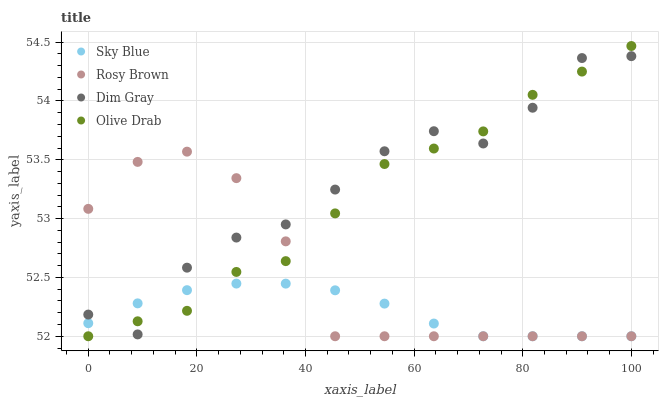Does Sky Blue have the minimum area under the curve?
Answer yes or no. Yes. Does Dim Gray have the maximum area under the curve?
Answer yes or no. Yes. Does Rosy Brown have the minimum area under the curve?
Answer yes or no. No. Does Rosy Brown have the maximum area under the curve?
Answer yes or no. No. Is Sky Blue the smoothest?
Answer yes or no. Yes. Is Dim Gray the roughest?
Answer yes or no. Yes. Is Rosy Brown the smoothest?
Answer yes or no. No. Is Rosy Brown the roughest?
Answer yes or no. No. Does Sky Blue have the lowest value?
Answer yes or no. Yes. Does Dim Gray have the lowest value?
Answer yes or no. No. Does Olive Drab have the highest value?
Answer yes or no. Yes. Does Dim Gray have the highest value?
Answer yes or no. No. Does Olive Drab intersect Sky Blue?
Answer yes or no. Yes. Is Olive Drab less than Sky Blue?
Answer yes or no. No. Is Olive Drab greater than Sky Blue?
Answer yes or no. No. 